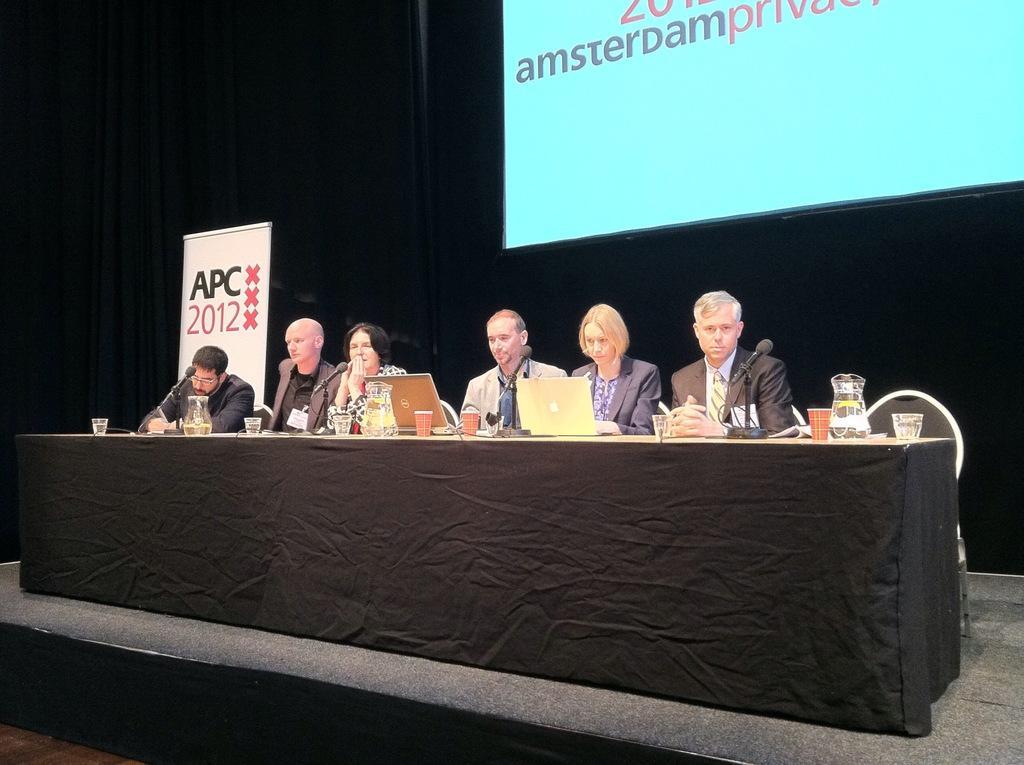Please provide a concise description of this image. In this image we can see the people sitting on the chairs in front of the table and on the table we can see the glasses, jugs, laptops and also mike's. In the background we can see the black color curtain and also the display screen with the text. We can also see the banner with the text. 